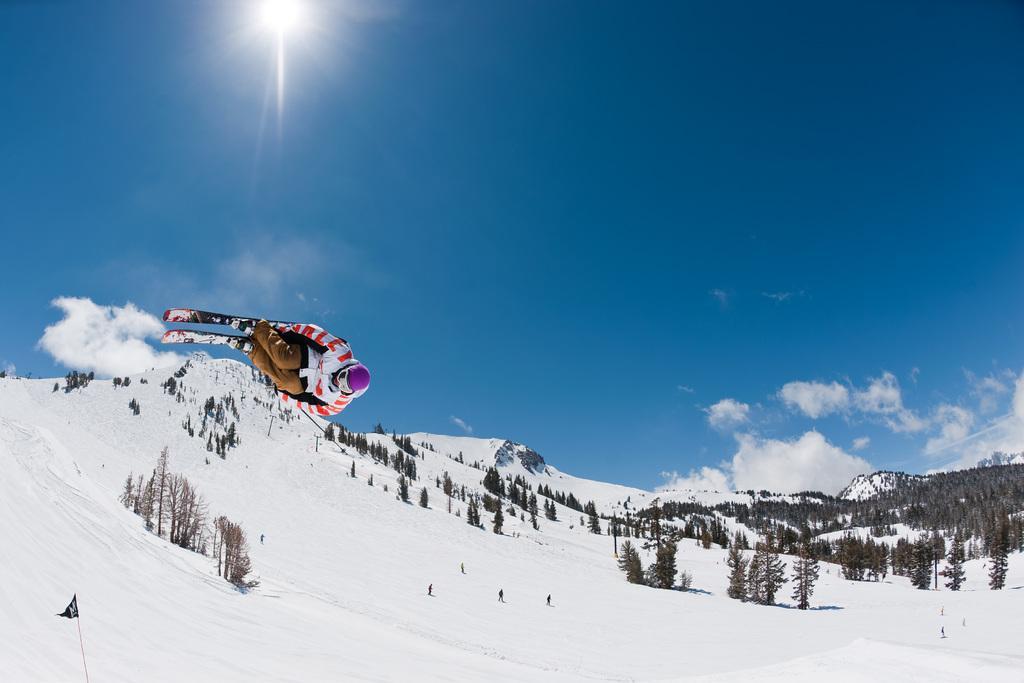Describe this image in one or two sentences. The person wearing white and red dress is skiing and there are trees and snow in the background. 